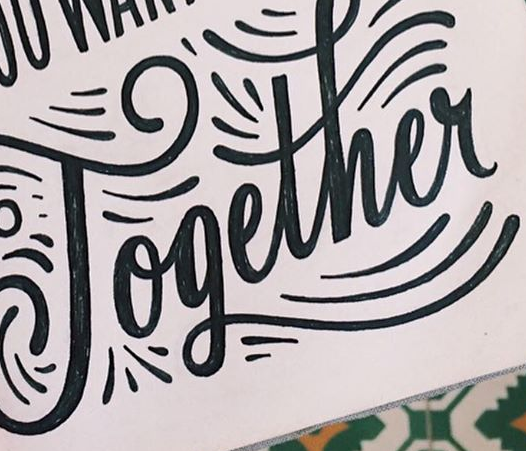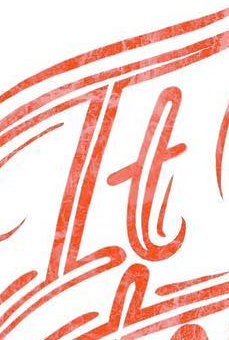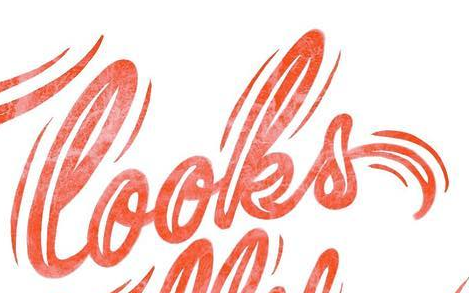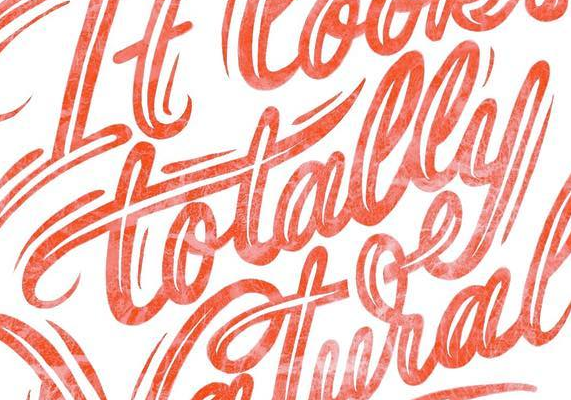What words are shown in these images in order, separated by a semicolon? Together; It; looks; totally 